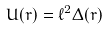<formula> <loc_0><loc_0><loc_500><loc_500>U ( r ) = \ell ^ { 2 } \Delta ( r )</formula> 